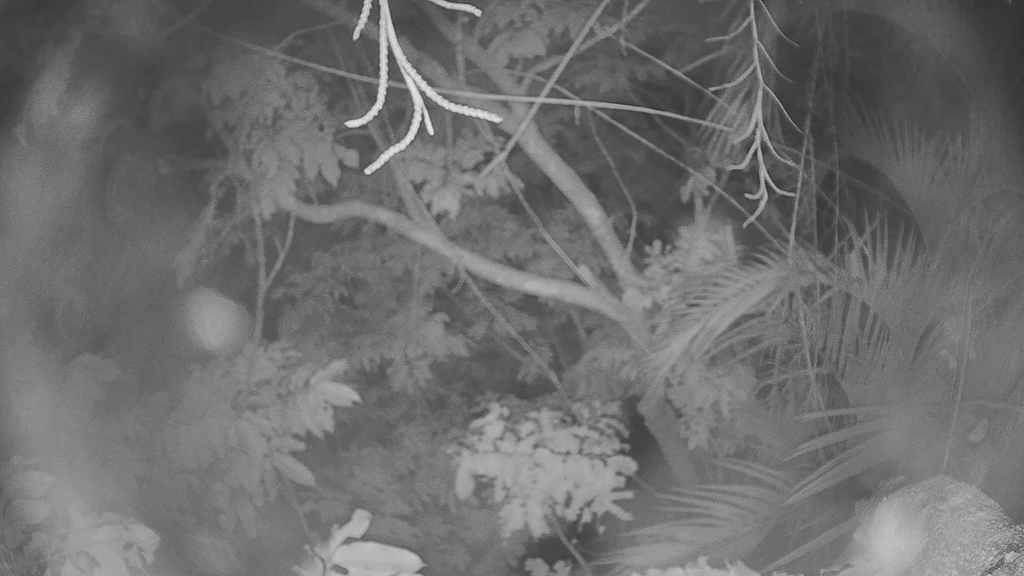What type of vegetation can be seen in the image? There are tree branches and leaves in the image. What is the color scheme of the image? The image is black and white in color. Where is the tray located in the image? There is no tray present in the image. What type of fowl can be seen in the image? There are no birds or fowl present in the image. 